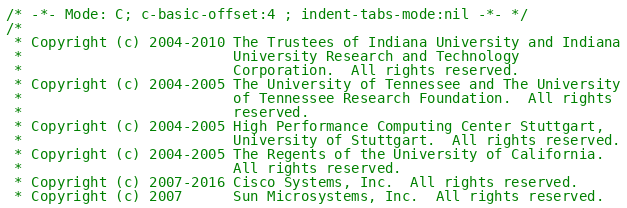Convert code to text. <code><loc_0><loc_0><loc_500><loc_500><_C_>/* -*- Mode: C; c-basic-offset:4 ; indent-tabs-mode:nil -*- */
/*
 * Copyright (c) 2004-2010 The Trustees of Indiana University and Indiana
 *                         University Research and Technology
 *                         Corporation.  All rights reserved.
 * Copyright (c) 2004-2005 The University of Tennessee and The University
 *                         of Tennessee Research Foundation.  All rights
 *                         reserved.
 * Copyright (c) 2004-2005 High Performance Computing Center Stuttgart,
 *                         University of Stuttgart.  All rights reserved.
 * Copyright (c) 2004-2005 The Regents of the University of California.
 *                         All rights reserved.
 * Copyright (c) 2007-2016 Cisco Systems, Inc.  All rights reserved.
 * Copyright (c) 2007      Sun Microsystems, Inc.  All rights reserved.</code> 